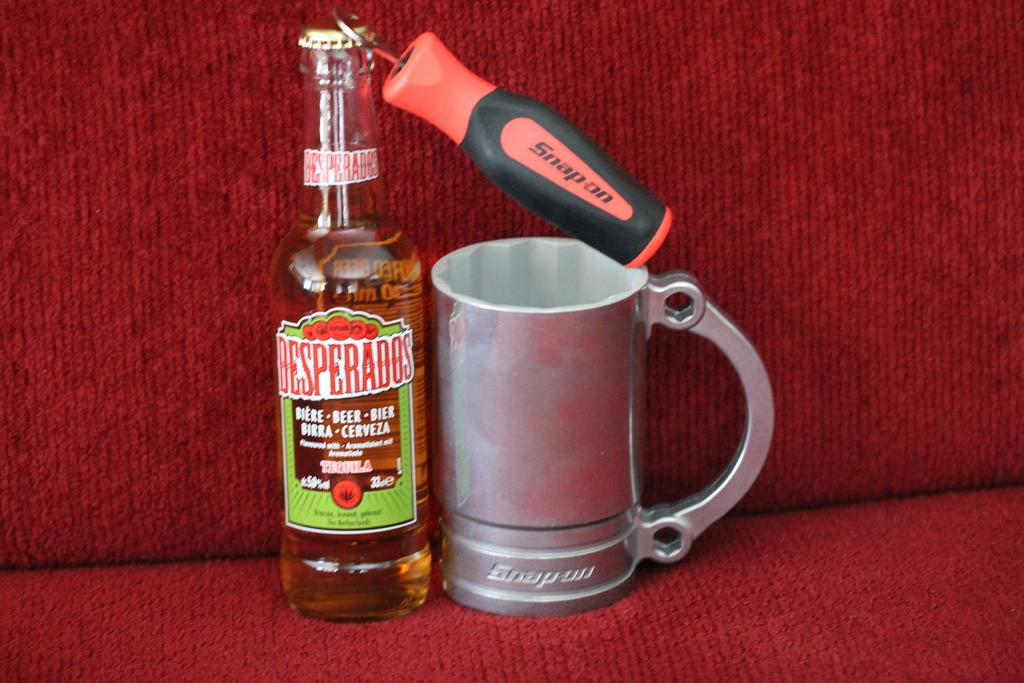What type of beverage container is in the image? There is a wine bottle in the image. What tool is present in the image that can be used to open the wine bottle? There is an opener in the image. What type of glass is visible in the image? There is a glass in the image. Where are the wine bottle, opener, and glass located in the image? The wine bottle, opener, and glass are on a sofa. What type of committee is meeting on the sofa in the image? There is no committee meeting on the sofa in the image; it only features a wine bottle, opener, and glass. What type of cream is being applied to the hole in the image? There is no cream or hole present in the image. 